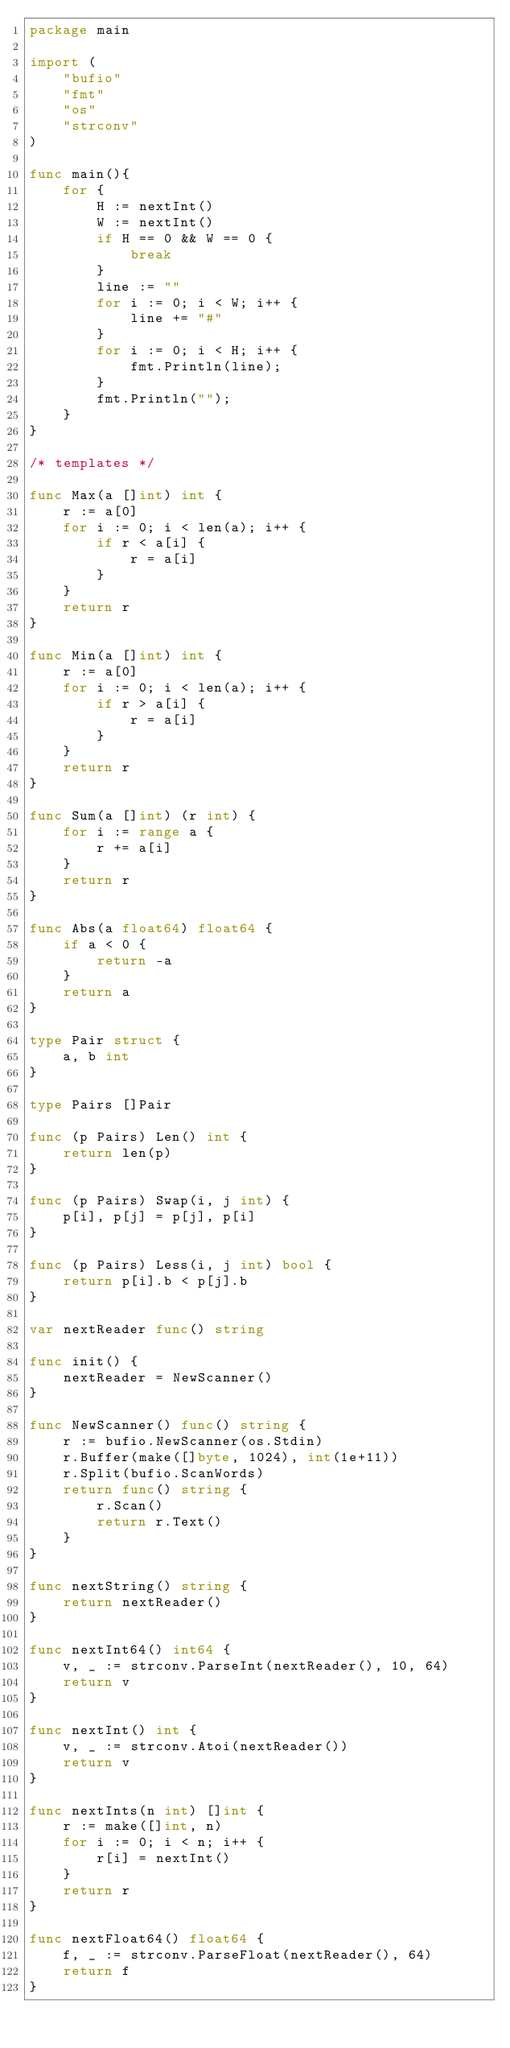Convert code to text. <code><loc_0><loc_0><loc_500><loc_500><_Go_>package main
 
import (
    "bufio"
    "fmt"
    "os"
    "strconv"
)

func main(){
    for {
        H := nextInt()
        W := nextInt()
        if H == 0 && W == 0 {
            break
        }
        line := ""
        for i := 0; i < W; i++ {
            line += "#"
        }
        for i := 0; i < H; i++ {
            fmt.Println(line);
        }
        fmt.Println("");
    }    
}
 
/* templates */
 
func Max(a []int) int {
    r := a[0]
    for i := 0; i < len(a); i++ {
        if r < a[i] {
            r = a[i]
        }
    }
    return r
}
 
func Min(a []int) int {
    r := a[0]
    for i := 0; i < len(a); i++ {
        if r > a[i] {
            r = a[i]
        }
    }
    return r
}
 
func Sum(a []int) (r int) {
    for i := range a {
        r += a[i]
    }
    return r
}
 
func Abs(a float64) float64 {
    if a < 0 {
        return -a
    }
    return a
}
 
type Pair struct {
    a, b int
}
 
type Pairs []Pair
 
func (p Pairs) Len() int {
    return len(p)
}
 
func (p Pairs) Swap(i, j int) {
    p[i], p[j] = p[j], p[i]
}
 
func (p Pairs) Less(i, j int) bool {
    return p[i].b < p[j].b
}
 
var nextReader func() string
 
func init() {
    nextReader = NewScanner()
}
 
func NewScanner() func() string {
    r := bufio.NewScanner(os.Stdin)
    r.Buffer(make([]byte, 1024), int(1e+11))
    r.Split(bufio.ScanWords)
    return func() string {
        r.Scan()
        return r.Text()
    }
}
 
func nextString() string {
    return nextReader()
}
 
func nextInt64() int64 {
    v, _ := strconv.ParseInt(nextReader(), 10, 64)
    return v
}
 
func nextInt() int {
    v, _ := strconv.Atoi(nextReader())
    return v
}
 
func nextInts(n int) []int {
    r := make([]int, n)
    for i := 0; i < n; i++ {
        r[i] = nextInt()
    }
    return r
}
 
func nextFloat64() float64 {
    f, _ := strconv.ParseFloat(nextReader(), 64)
    return f
}
</code> 